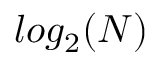Convert formula to latex. <formula><loc_0><loc_0><loc_500><loc_500>\log _ { 2 } ( N )</formula> 